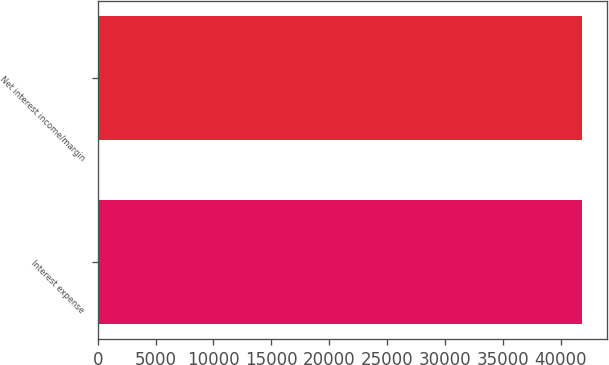<chart> <loc_0><loc_0><loc_500><loc_500><bar_chart><fcel>Interest expense<fcel>Net interest income/margin<nl><fcel>41885<fcel>41885.1<nl></chart> 